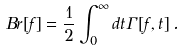<formula> <loc_0><loc_0><loc_500><loc_500>B r [ f ] = \frac { 1 } { 2 } \int ^ { \infty } _ { 0 } { d t \Gamma [ f , t ] } \, .</formula> 